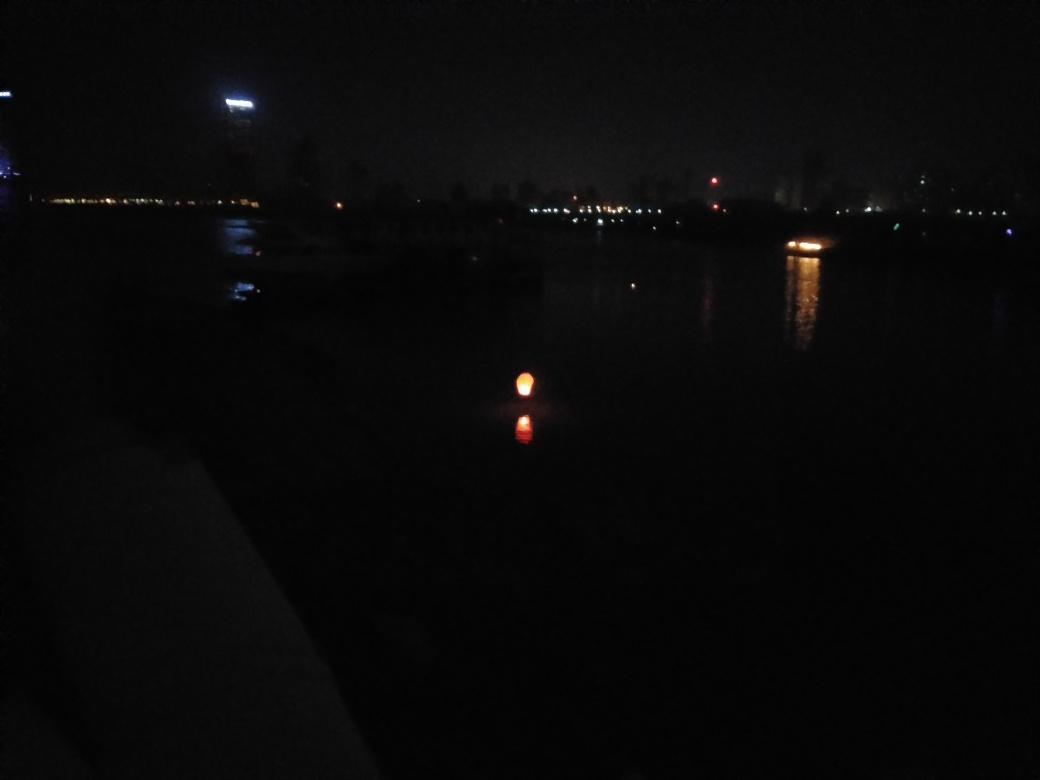What can we deduce about the location based on the lights and structures in the background? The sparse city lights and silhouettes of buildings in the distance hint that this could be a view from a waterfront area looking towards an urban skyline. The lights are too faint to determine the specifics of the structures, but they suggest a cityscape. 